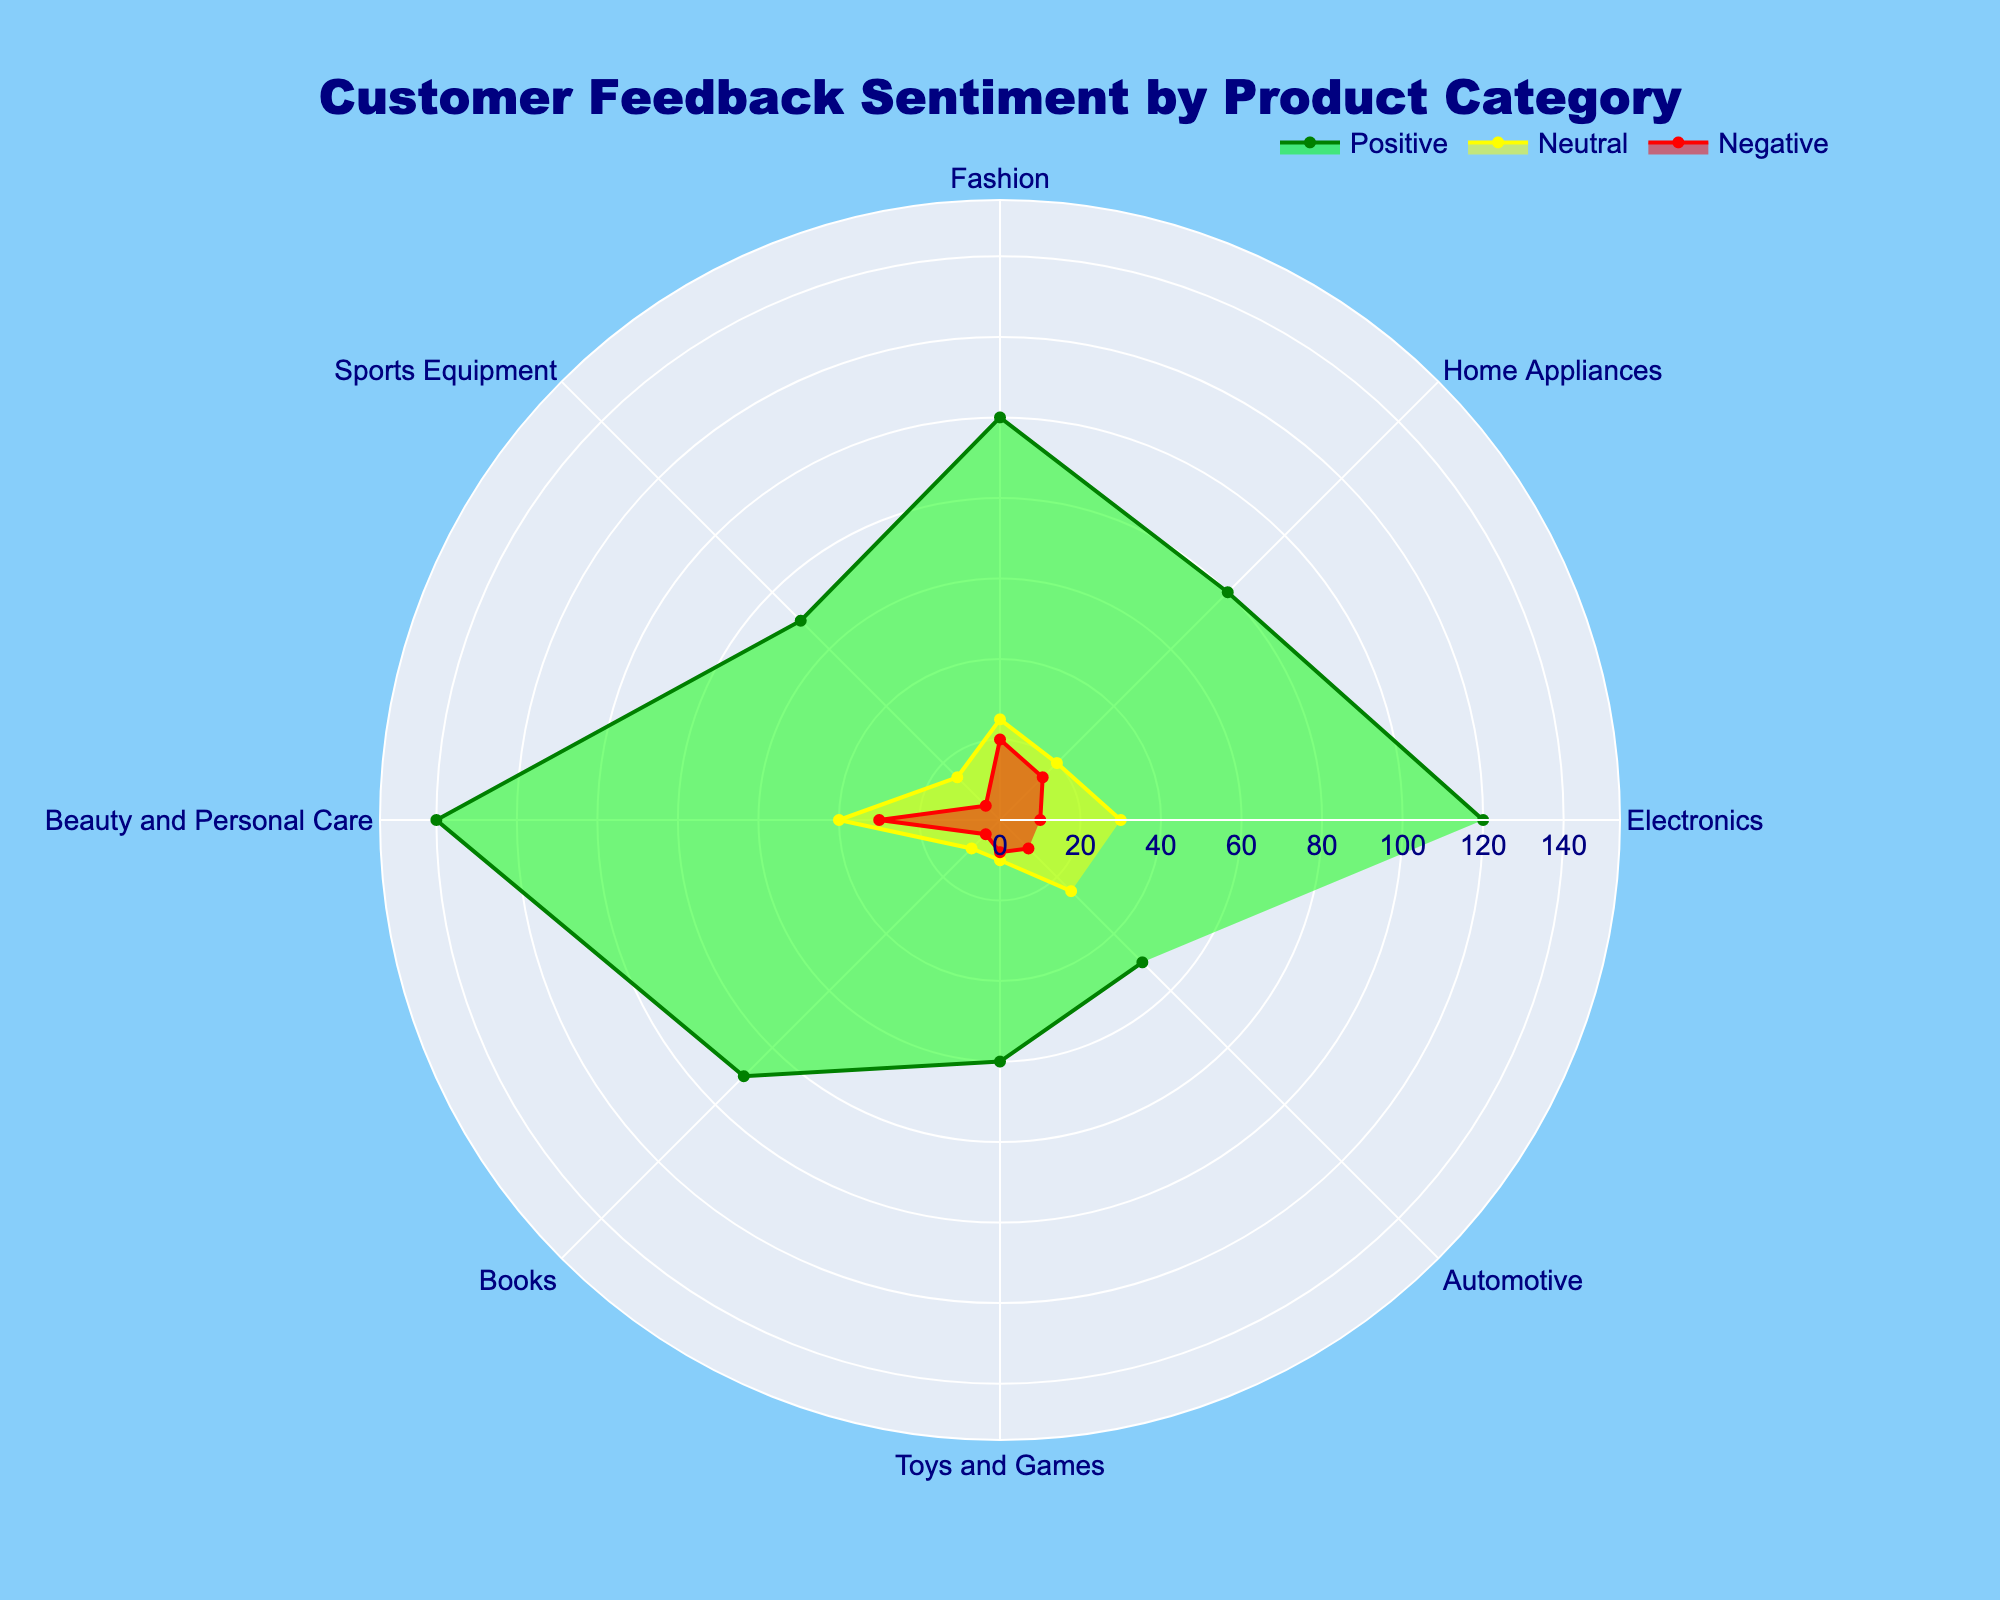What is the title of the plot? The title is displayed at the top of the figure in larger font and reads "Customer Feedback Sentiment by Product Category".
Answer: Customer Feedback Sentiment by Product Category Which product category has the highest positive feedback? By examining the green area (representing positive feedback) in the polar chart, the segment with the largest radius corresponds to "Beauty and Personal Care".
Answer: Beauty and Personal Care What is the total number of feedback (positive, neutral, and negative) for Electronics? Add the three values for each sentiment in the Electronics category: 120 (positive) + 30 (neutral) + 10 (negative) = 160.
Answer: 160 Which product category has the highest neutral feedback? By looking at the yellow area (representing neutral feedback), the segment with the largest radius corresponds to "Beauty and Personal Care".
Answer: Beauty and Personal Care Which product category has the lowest negative feedback? Looking at the red area (representing negative feedback), the segment with the smallest radius corresponds to "Sports Equipment".
Answer: Sports Equipment How does the neutral feedback for Books compare to that for Automotive? Compare the two values in the yellow area; Books have a neutral feedback of 10, and Automotive has 25. Since 10 is less than 25, Books have less neutral feedback than Automotive.
Answer: Books have less neutral feedback than Automotive What is the average positive feedback across all product categories? Sum all the positive feedback values and divide by the number of categories: (120 + 80 + 100 + 70 + 140 + 90 + 60 + 50) / 8 = 710 / 8 = 88.75.
Answer: 88.75 What is the sum of neutral feedback for Electronics and Fashion? Add the neutral feedback values for Electronics and Fashion: 30 (Electronics) + 25 (Fashion) = 55.
Answer: 55 Which product category has the smallest total feedback? Calculate the total feedback for each category and determine the smallest sum. Toys and Games have 60 (positive) + 10 (neutral) + 8 (negative) = 78, which is the smallest.
Answer: Toys and Games What's the difference in positive feedback between Fashion and Home Appliances? Subtract the positive feedback value for Home Appliances from that for Fashion: 100 (Fashion) - 80 (Home Appliances) = 20.
Answer: 20 